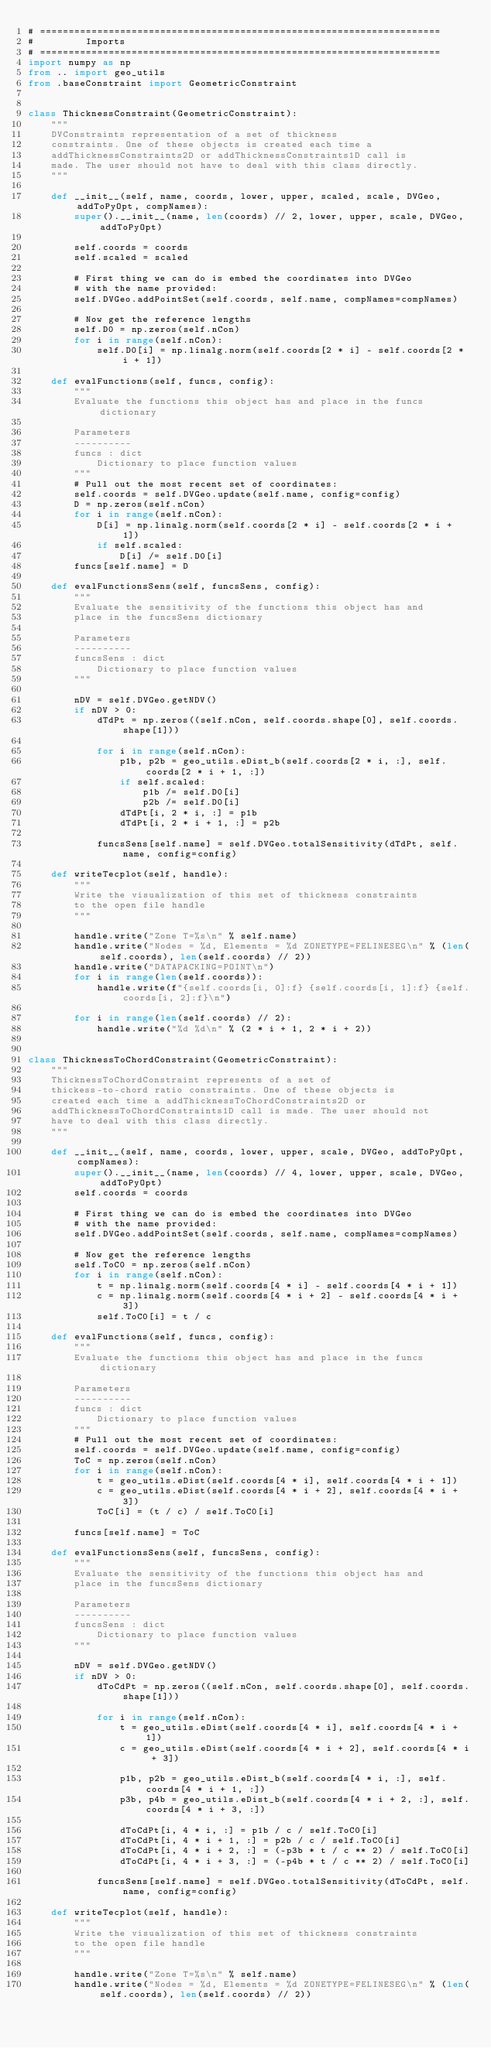Convert code to text. <code><loc_0><loc_0><loc_500><loc_500><_Python_># ======================================================================
#         Imports
# ======================================================================
import numpy as np
from .. import geo_utils
from .baseConstraint import GeometricConstraint


class ThicknessConstraint(GeometricConstraint):
    """
    DVConstraints representation of a set of thickness
    constraints. One of these objects is created each time a
    addThicknessConstraints2D or addThicknessConstraints1D call is
    made. The user should not have to deal with this class directly.
    """

    def __init__(self, name, coords, lower, upper, scaled, scale, DVGeo, addToPyOpt, compNames):
        super().__init__(name, len(coords) // 2, lower, upper, scale, DVGeo, addToPyOpt)

        self.coords = coords
        self.scaled = scaled

        # First thing we can do is embed the coordinates into DVGeo
        # with the name provided:
        self.DVGeo.addPointSet(self.coords, self.name, compNames=compNames)

        # Now get the reference lengths
        self.D0 = np.zeros(self.nCon)
        for i in range(self.nCon):
            self.D0[i] = np.linalg.norm(self.coords[2 * i] - self.coords[2 * i + 1])

    def evalFunctions(self, funcs, config):
        """
        Evaluate the functions this object has and place in the funcs dictionary

        Parameters
        ----------
        funcs : dict
            Dictionary to place function values
        """
        # Pull out the most recent set of coordinates:
        self.coords = self.DVGeo.update(self.name, config=config)
        D = np.zeros(self.nCon)
        for i in range(self.nCon):
            D[i] = np.linalg.norm(self.coords[2 * i] - self.coords[2 * i + 1])
            if self.scaled:
                D[i] /= self.D0[i]
        funcs[self.name] = D

    def evalFunctionsSens(self, funcsSens, config):
        """
        Evaluate the sensitivity of the functions this object has and
        place in the funcsSens dictionary

        Parameters
        ----------
        funcsSens : dict
            Dictionary to place function values
        """

        nDV = self.DVGeo.getNDV()
        if nDV > 0:
            dTdPt = np.zeros((self.nCon, self.coords.shape[0], self.coords.shape[1]))

            for i in range(self.nCon):
                p1b, p2b = geo_utils.eDist_b(self.coords[2 * i, :], self.coords[2 * i + 1, :])
                if self.scaled:
                    p1b /= self.D0[i]
                    p2b /= self.D0[i]
                dTdPt[i, 2 * i, :] = p1b
                dTdPt[i, 2 * i + 1, :] = p2b

            funcsSens[self.name] = self.DVGeo.totalSensitivity(dTdPt, self.name, config=config)

    def writeTecplot(self, handle):
        """
        Write the visualization of this set of thickness constraints
        to the open file handle
        """

        handle.write("Zone T=%s\n" % self.name)
        handle.write("Nodes = %d, Elements = %d ZONETYPE=FELINESEG\n" % (len(self.coords), len(self.coords) // 2))
        handle.write("DATAPACKING=POINT\n")
        for i in range(len(self.coords)):
            handle.write(f"{self.coords[i, 0]:f} {self.coords[i, 1]:f} {self.coords[i, 2]:f}\n")

        for i in range(len(self.coords) // 2):
            handle.write("%d %d\n" % (2 * i + 1, 2 * i + 2))


class ThicknessToChordConstraint(GeometricConstraint):
    """
    ThicknessToChordConstraint represents of a set of
    thickess-to-chord ratio constraints. One of these objects is
    created each time a addThicknessToChordConstraints2D or
    addThicknessToChordConstraints1D call is made. The user should not
    have to deal with this class directly.
    """

    def __init__(self, name, coords, lower, upper, scale, DVGeo, addToPyOpt, compNames):
        super().__init__(name, len(coords) // 4, lower, upper, scale, DVGeo, addToPyOpt)
        self.coords = coords

        # First thing we can do is embed the coordinates into DVGeo
        # with the name provided:
        self.DVGeo.addPointSet(self.coords, self.name, compNames=compNames)

        # Now get the reference lengths
        self.ToC0 = np.zeros(self.nCon)
        for i in range(self.nCon):
            t = np.linalg.norm(self.coords[4 * i] - self.coords[4 * i + 1])
            c = np.linalg.norm(self.coords[4 * i + 2] - self.coords[4 * i + 3])
            self.ToC0[i] = t / c

    def evalFunctions(self, funcs, config):
        """
        Evaluate the functions this object has and place in the funcs dictionary

        Parameters
        ----------
        funcs : dict
            Dictionary to place function values
        """
        # Pull out the most recent set of coordinates:
        self.coords = self.DVGeo.update(self.name, config=config)
        ToC = np.zeros(self.nCon)
        for i in range(self.nCon):
            t = geo_utils.eDist(self.coords[4 * i], self.coords[4 * i + 1])
            c = geo_utils.eDist(self.coords[4 * i + 2], self.coords[4 * i + 3])
            ToC[i] = (t / c) / self.ToC0[i]

        funcs[self.name] = ToC

    def evalFunctionsSens(self, funcsSens, config):
        """
        Evaluate the sensitivity of the functions this object has and
        place in the funcsSens dictionary

        Parameters
        ----------
        funcsSens : dict
            Dictionary to place function values
        """

        nDV = self.DVGeo.getNDV()
        if nDV > 0:
            dToCdPt = np.zeros((self.nCon, self.coords.shape[0], self.coords.shape[1]))

            for i in range(self.nCon):
                t = geo_utils.eDist(self.coords[4 * i], self.coords[4 * i + 1])
                c = geo_utils.eDist(self.coords[4 * i + 2], self.coords[4 * i + 3])

                p1b, p2b = geo_utils.eDist_b(self.coords[4 * i, :], self.coords[4 * i + 1, :])
                p3b, p4b = geo_utils.eDist_b(self.coords[4 * i + 2, :], self.coords[4 * i + 3, :])

                dToCdPt[i, 4 * i, :] = p1b / c / self.ToC0[i]
                dToCdPt[i, 4 * i + 1, :] = p2b / c / self.ToC0[i]
                dToCdPt[i, 4 * i + 2, :] = (-p3b * t / c ** 2) / self.ToC0[i]
                dToCdPt[i, 4 * i + 3, :] = (-p4b * t / c ** 2) / self.ToC0[i]

            funcsSens[self.name] = self.DVGeo.totalSensitivity(dToCdPt, self.name, config=config)

    def writeTecplot(self, handle):
        """
        Write the visualization of this set of thickness constraints
        to the open file handle
        """

        handle.write("Zone T=%s\n" % self.name)
        handle.write("Nodes = %d, Elements = %d ZONETYPE=FELINESEG\n" % (len(self.coords), len(self.coords) // 2))</code> 